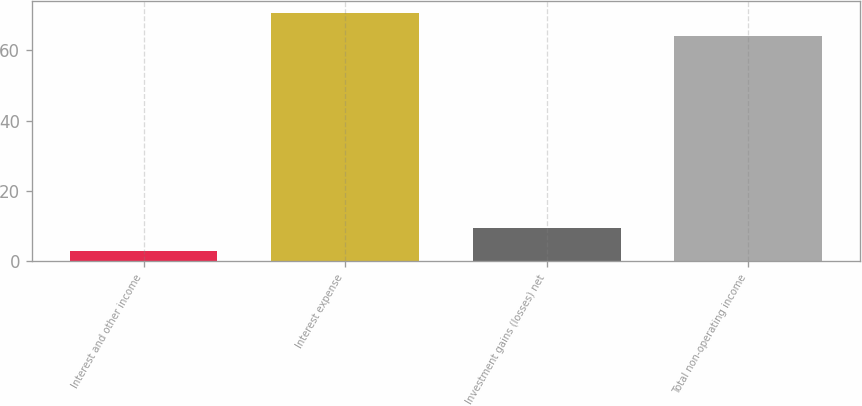Convert chart to OTSL. <chart><loc_0><loc_0><loc_500><loc_500><bar_chart><fcel>Interest and other income<fcel>Interest expense<fcel>Investment gains (losses) net<fcel>Total non-operating income<nl><fcel>3<fcel>70.5<fcel>9.4<fcel>64.1<nl></chart> 